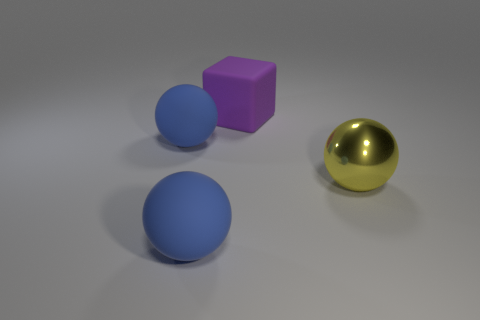What material is the big ball to the right of the big block? Judging by the reflective surface and the way it interacts with light, the big, gold-colored ball to the right of the purple block appears to be made of a polished metallic material, such as brass or gold, which is often used in computer-generated imagery to showcase reflections and highlights. 